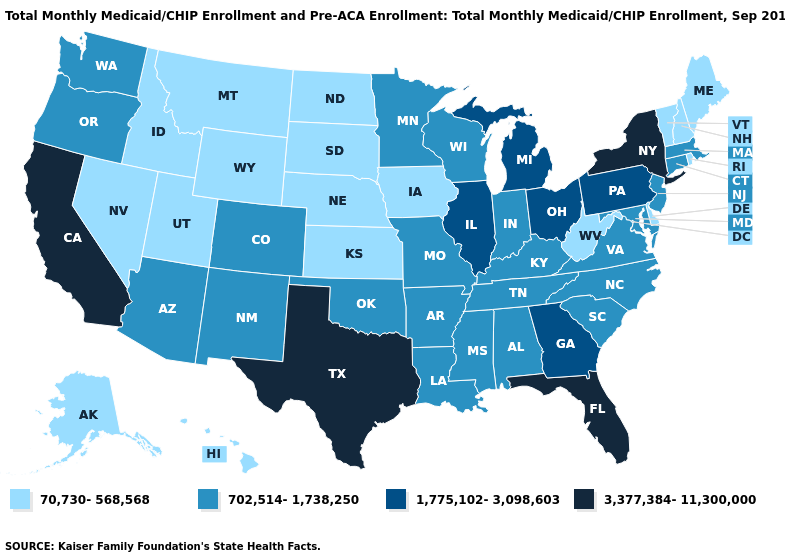Which states have the lowest value in the USA?
Be succinct. Alaska, Delaware, Hawaii, Idaho, Iowa, Kansas, Maine, Montana, Nebraska, Nevada, New Hampshire, North Dakota, Rhode Island, South Dakota, Utah, Vermont, West Virginia, Wyoming. Does Vermont have the highest value in the USA?
Keep it brief. No. What is the value of Illinois?
Concise answer only. 1,775,102-3,098,603. Name the states that have a value in the range 3,377,384-11,300,000?
Answer briefly. California, Florida, New York, Texas. Name the states that have a value in the range 702,514-1,738,250?
Concise answer only. Alabama, Arizona, Arkansas, Colorado, Connecticut, Indiana, Kentucky, Louisiana, Maryland, Massachusetts, Minnesota, Mississippi, Missouri, New Jersey, New Mexico, North Carolina, Oklahoma, Oregon, South Carolina, Tennessee, Virginia, Washington, Wisconsin. What is the lowest value in the USA?
Quick response, please. 70,730-568,568. Name the states that have a value in the range 70,730-568,568?
Give a very brief answer. Alaska, Delaware, Hawaii, Idaho, Iowa, Kansas, Maine, Montana, Nebraska, Nevada, New Hampshire, North Dakota, Rhode Island, South Dakota, Utah, Vermont, West Virginia, Wyoming. What is the lowest value in the USA?
Concise answer only. 70,730-568,568. What is the value of California?
Give a very brief answer. 3,377,384-11,300,000. Among the states that border New Hampshire , does Massachusetts have the highest value?
Give a very brief answer. Yes. Name the states that have a value in the range 1,775,102-3,098,603?
Quick response, please. Georgia, Illinois, Michigan, Ohio, Pennsylvania. What is the lowest value in the South?
Short answer required. 70,730-568,568. Name the states that have a value in the range 702,514-1,738,250?
Concise answer only. Alabama, Arizona, Arkansas, Colorado, Connecticut, Indiana, Kentucky, Louisiana, Maryland, Massachusetts, Minnesota, Mississippi, Missouri, New Jersey, New Mexico, North Carolina, Oklahoma, Oregon, South Carolina, Tennessee, Virginia, Washington, Wisconsin. Among the states that border Wyoming , which have the lowest value?
Answer briefly. Idaho, Montana, Nebraska, South Dakota, Utah. Does North Carolina have the same value as New Mexico?
Write a very short answer. Yes. 